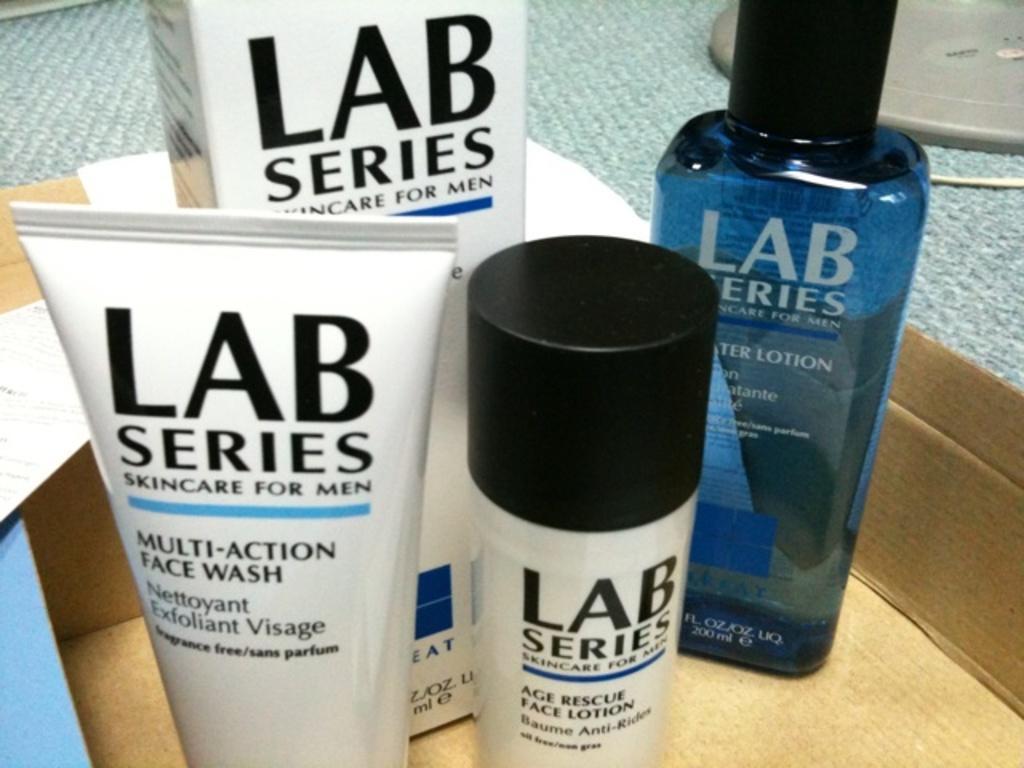Can you describe this image briefly? In this picture I can see there are some lotion, face wash and these are placed in the carton box and these are placed on the grey surface. 